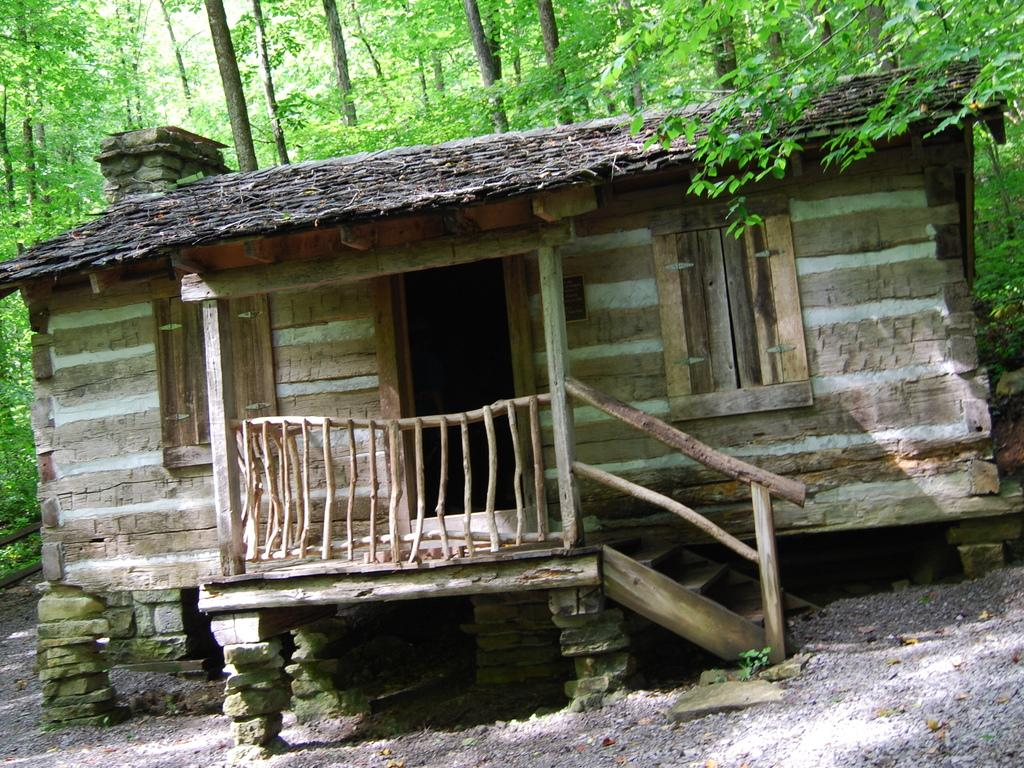What type of house is in the image? There is a wooden house in the image. What features can be seen on the house? The house has windows and a door. What is located near the house in the image? There is a wooden railing and stairs in the image. What type of natural elements are present in the image? There are trees in the image. What causes the house to burst into flames in the image? There is no indication of a fire or any flames in the image, so the house does not burst into flames. 